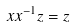<formula> <loc_0><loc_0><loc_500><loc_500>x x ^ { - 1 } z = z</formula> 